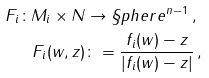<formula> <loc_0><loc_0><loc_500><loc_500>F _ { i } \colon M _ { i } \times N & \to \S p h e r e ^ { n - 1 } \, , \\ F _ { i } ( w , z ) & \colon = \frac { f _ { i } ( w ) - z } { | f _ { i } ( w ) - z | } \, ,</formula> 